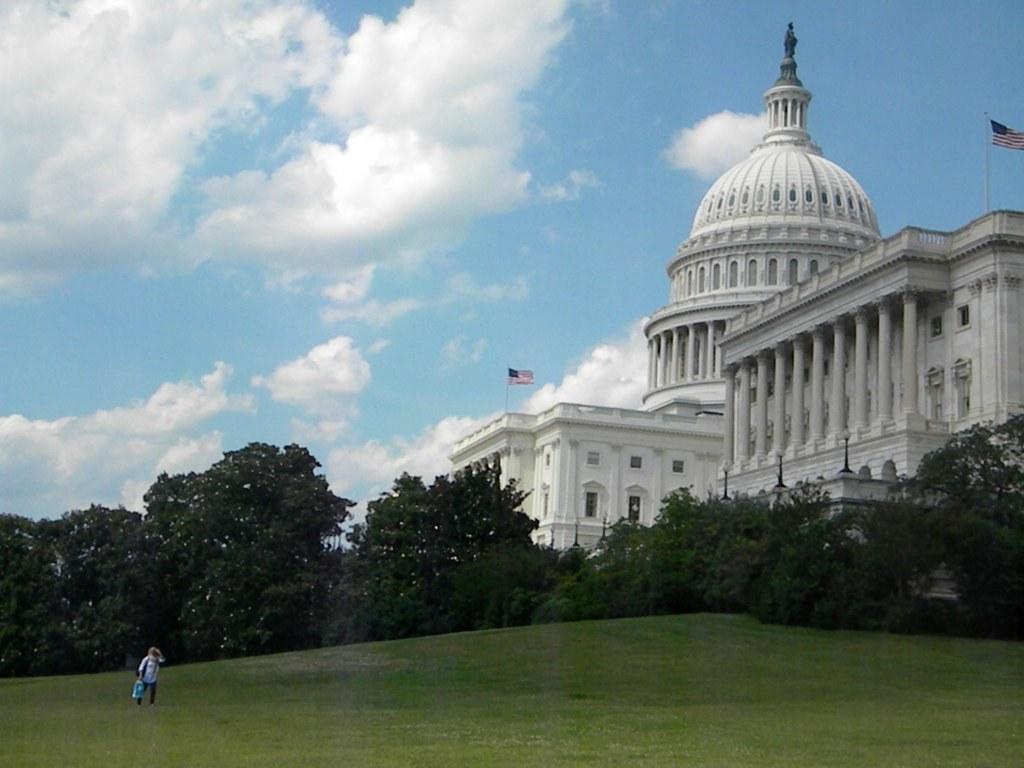Describe this image in one or two sentences. In this image there is a person holding the bag. At the bottom of the image there is grass on the surface. In the background of the image there are trees, buildings, light poles, flags and sky. 